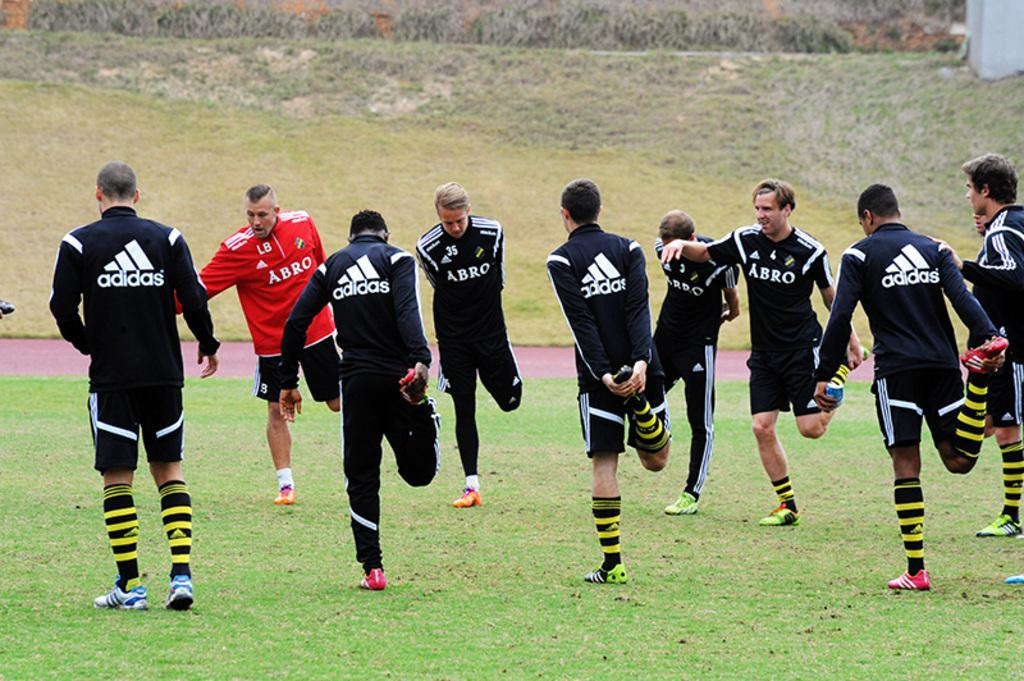Provide a one-sentence caption for the provided image. Men wearing Adidas warmups are stretching out on a field. 